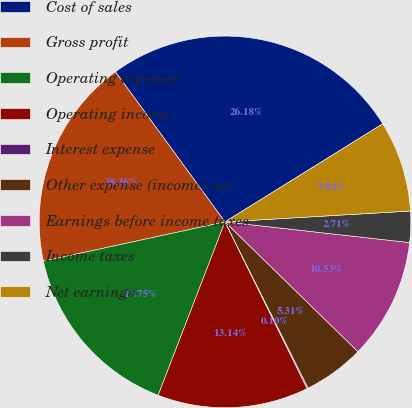Convert chart. <chart><loc_0><loc_0><loc_500><loc_500><pie_chart><fcel>Cost of sales<fcel>Gross profit<fcel>Operating expenses<fcel>Operating income<fcel>Interest expense<fcel>Other expense (income) net<fcel>Earnings before income taxes<fcel>Income taxes<fcel>Net earnings<nl><fcel>26.18%<fcel>18.36%<fcel>15.75%<fcel>13.14%<fcel>0.1%<fcel>5.31%<fcel>10.53%<fcel>2.71%<fcel>7.92%<nl></chart> 